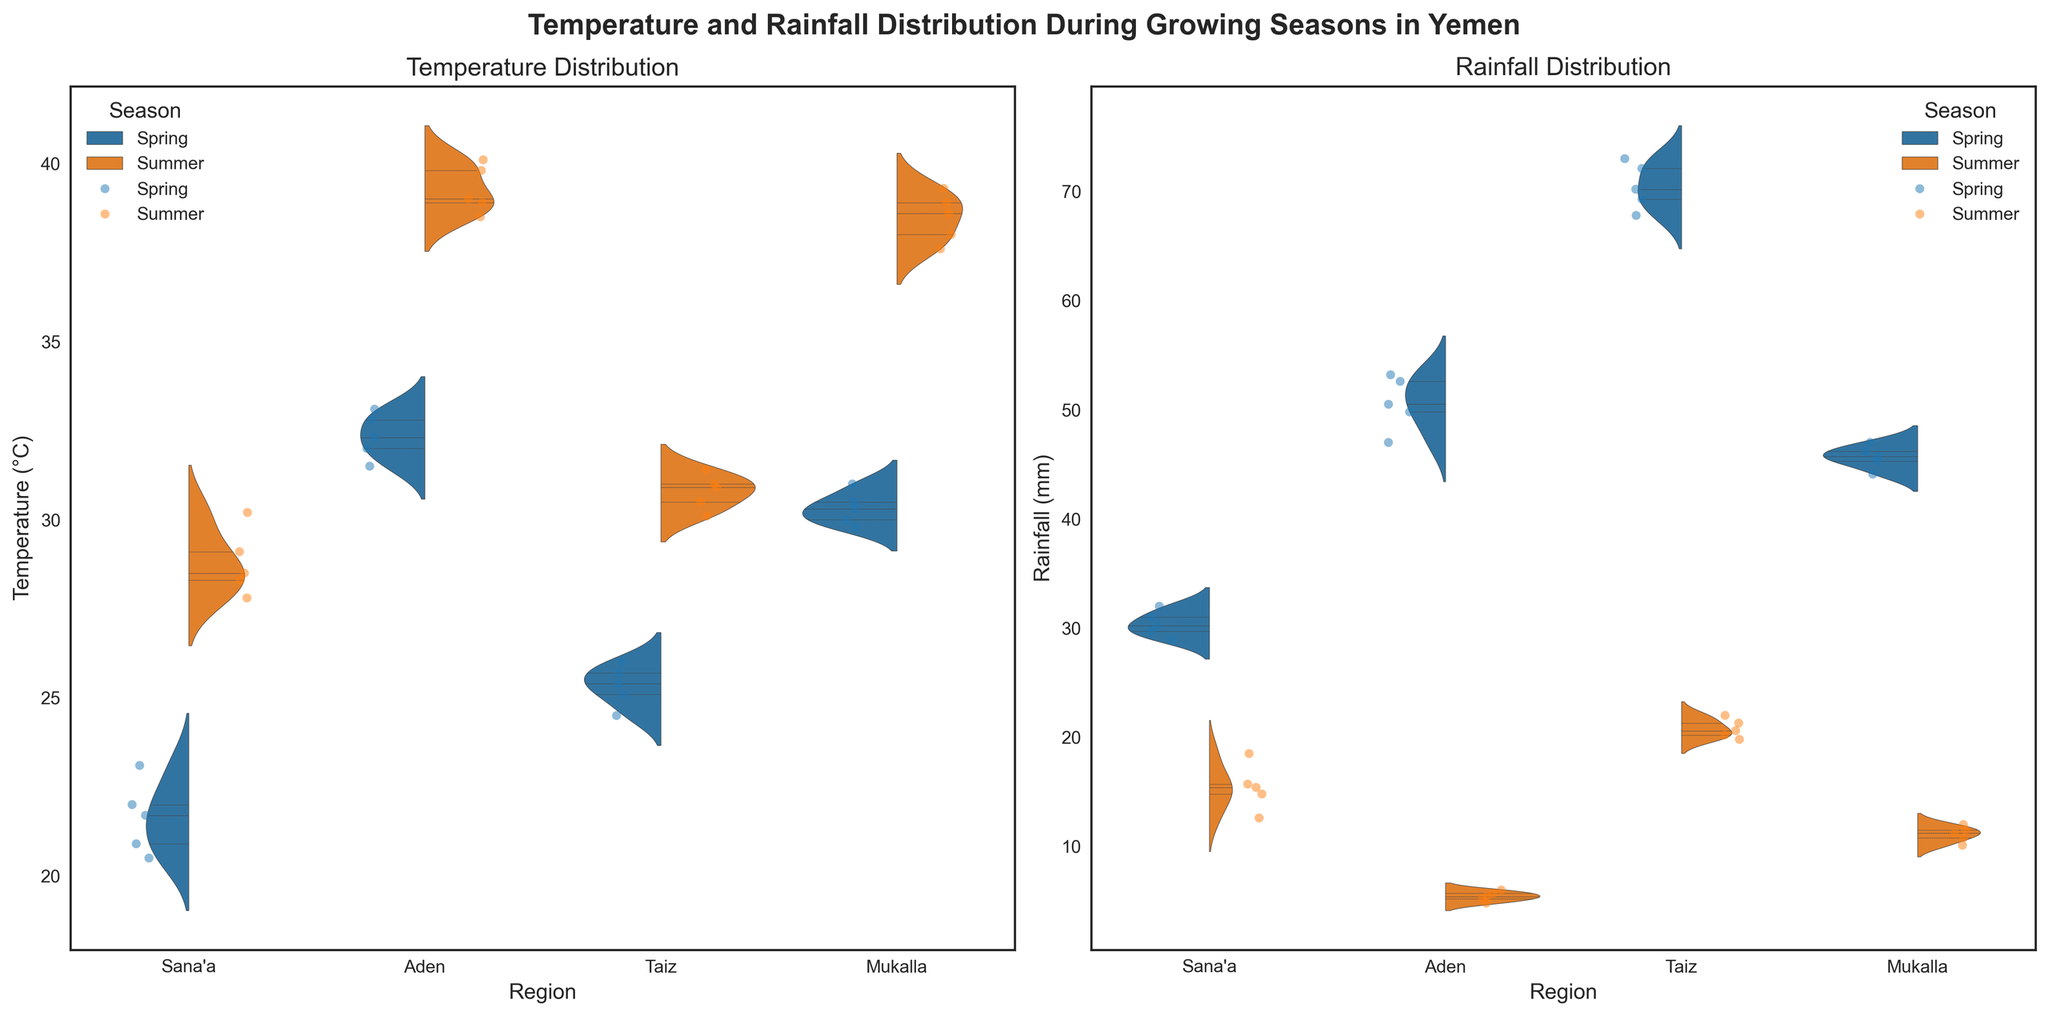What is the title of the figure? The title is displayed at the top center of the figure. It serves as an introduction and summary of what the figure represents. The title here is "Temperature and Rainfall Distribution During Growing Seasons in Yemen."
Answer: Temperature and Rainfall Distribution During Growing Seasons in Yemen Which region has the highest median temperature in the summer? From the violin plots, the median temperature is indicated by the thick white line in the inner part of each violin. By comparing these lines for the summer temperatures across the regions, it's clear that Aden has the highest median temperature.
Answer: Aden What is the range of rainfall in Taiz during spring? The range can be determined by looking at the top and bottom points of the violin plot for rainfall in Taiz during spring. These points represent the maximum and minimum values.
Answer: 67.8 mm to 73.0 mm How do the rainfall distributions in Sana'a and Taiz during spring compare? Comparing the violin plots for rainfall in both regions during spring, it's visible that Taiz has a higher overall range and median rainfall compared to Sana'a. This is indicated by the shapes and spread of the violins.
Answer: Taiz has higher and more varied rainfall Which season has less variability in rainfall in Mukalla? Variability can be assessed by looking at the width of the violins throughout their length. Narrower violins indicate less variability. In Mukalla, the summer violin plot is narrower compared to the spring plot, indicating less variability in summer rainfall.
Answer: Summer What are the approximate median temperatures in Aden during spring and summer? The median values are indicated by the white lines inside the violin plots. For Aden, the spring median is around 32.5°C, and the summer median is around 39.0°C.
Answer: Spring: 32.5°C, Summer: 39.0°C Which region has a more evenly distributed temperature in summer? The evenly distributed temperature can be seen where the violin plot is relatively symmetrical and has a consistent width throughout. Mukalla's and Taiz's violin plots for summer temperatures appear more evenly distributed compared to others.
Answer: Mukalla and Taiz Compare the median rainfall between Sana'a and Mukalla during summer. The median rainfall is shown by the white line in the middle of the violin plot. Comparing both, Sana'a has a summer median of about 14.8 mm, while Mukalla has around 11.2 mm. Sana'a has a higher median summer rainfall.
Answer: Sana'a has higher median summer rainfall Which region appears to have the most stable temperature between seasons? Stability can be inferred from the similarity in the shape and spread of the violin plots between the seasons. Sana'a shows similar spreads and medians for both seasons, indicating relatively stable temperatures.
Answer: Sana'a 